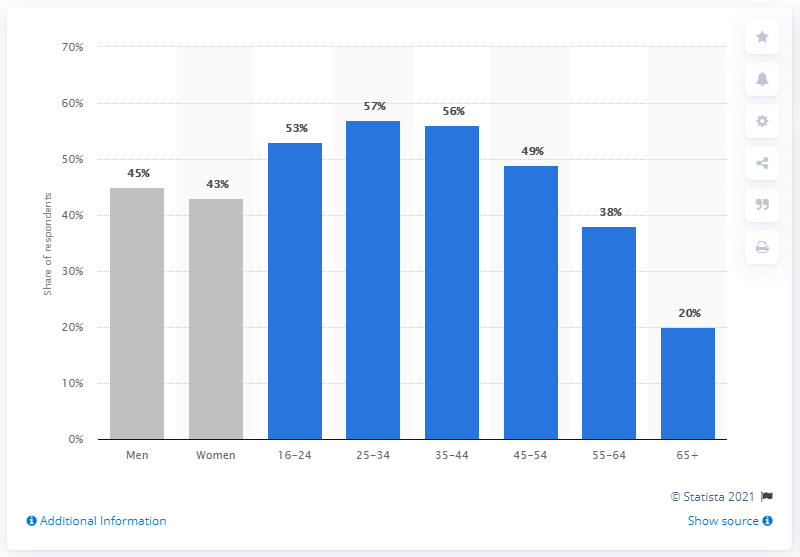Point out several critical features in this image. In 2019, 57% of 25 to 34 year olds purchased event tickets online, according to a recent survey. 